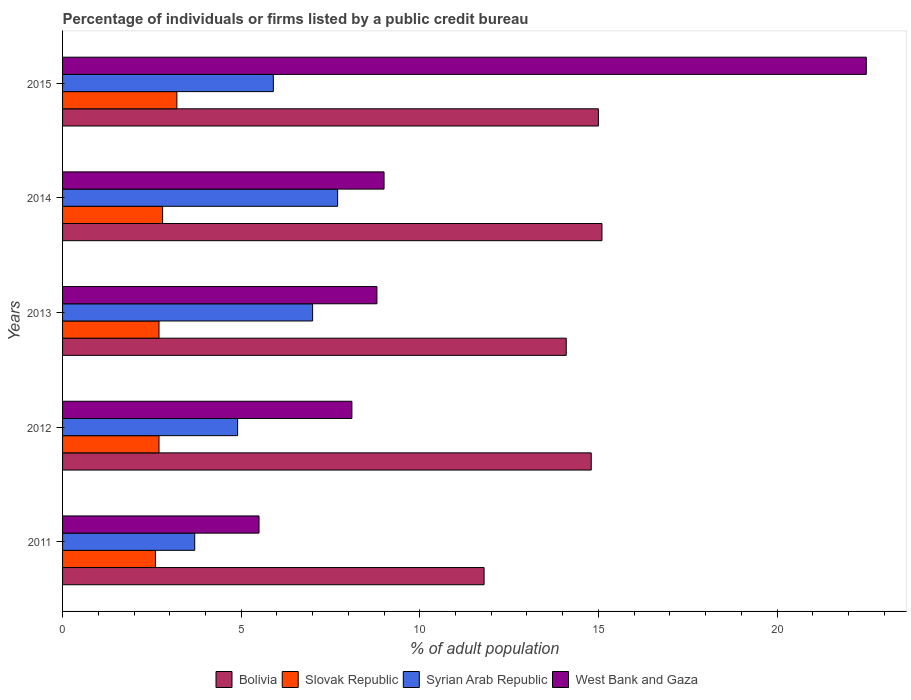How many different coloured bars are there?
Give a very brief answer. 4. How many groups of bars are there?
Provide a short and direct response. 5. Are the number of bars on each tick of the Y-axis equal?
Keep it short and to the point. Yes. How many bars are there on the 3rd tick from the top?
Your answer should be very brief. 4. How many bars are there on the 2nd tick from the bottom?
Your response must be concise. 4. In how many cases, is the number of bars for a given year not equal to the number of legend labels?
Offer a very short reply. 0. What is the percentage of population listed by a public credit bureau in Slovak Republic in 2013?
Offer a very short reply. 2.7. Across all years, what is the maximum percentage of population listed by a public credit bureau in Slovak Republic?
Give a very brief answer. 3.2. Across all years, what is the minimum percentage of population listed by a public credit bureau in Syrian Arab Republic?
Your answer should be compact. 3.7. In which year was the percentage of population listed by a public credit bureau in Slovak Republic maximum?
Keep it short and to the point. 2015. In which year was the percentage of population listed by a public credit bureau in Bolivia minimum?
Give a very brief answer. 2011. What is the difference between the percentage of population listed by a public credit bureau in Bolivia in 2011 and that in 2013?
Ensure brevity in your answer.  -2.3. What is the difference between the percentage of population listed by a public credit bureau in West Bank and Gaza in 2011 and the percentage of population listed by a public credit bureau in Syrian Arab Republic in 2015?
Keep it short and to the point. -0.4. What is the average percentage of population listed by a public credit bureau in West Bank and Gaza per year?
Provide a short and direct response. 10.78. In the year 2012, what is the difference between the percentage of population listed by a public credit bureau in Slovak Republic and percentage of population listed by a public credit bureau in West Bank and Gaza?
Make the answer very short. -5.4. In how many years, is the percentage of population listed by a public credit bureau in Bolivia greater than 8 %?
Your answer should be compact. 5. What is the ratio of the percentage of population listed by a public credit bureau in Bolivia in 2013 to that in 2014?
Offer a terse response. 0.93. Is the percentage of population listed by a public credit bureau in Bolivia in 2011 less than that in 2013?
Offer a very short reply. Yes. Is the difference between the percentage of population listed by a public credit bureau in Slovak Republic in 2014 and 2015 greater than the difference between the percentage of population listed by a public credit bureau in West Bank and Gaza in 2014 and 2015?
Offer a terse response. Yes. What is the difference between the highest and the lowest percentage of population listed by a public credit bureau in West Bank and Gaza?
Offer a terse response. 17. Is it the case that in every year, the sum of the percentage of population listed by a public credit bureau in Slovak Republic and percentage of population listed by a public credit bureau in Bolivia is greater than the sum of percentage of population listed by a public credit bureau in West Bank and Gaza and percentage of population listed by a public credit bureau in Syrian Arab Republic?
Keep it short and to the point. No. What does the 3rd bar from the top in 2012 represents?
Provide a short and direct response. Slovak Republic. What does the 2nd bar from the bottom in 2012 represents?
Offer a terse response. Slovak Republic. How many bars are there?
Ensure brevity in your answer.  20. Are all the bars in the graph horizontal?
Make the answer very short. Yes. How many years are there in the graph?
Offer a very short reply. 5. Where does the legend appear in the graph?
Provide a succinct answer. Bottom center. How many legend labels are there?
Keep it short and to the point. 4. What is the title of the graph?
Offer a very short reply. Percentage of individuals or firms listed by a public credit bureau. What is the label or title of the X-axis?
Provide a short and direct response. % of adult population. What is the % of adult population in Syrian Arab Republic in 2011?
Your response must be concise. 3.7. What is the % of adult population of West Bank and Gaza in 2011?
Ensure brevity in your answer.  5.5. What is the % of adult population in Bolivia in 2012?
Make the answer very short. 14.8. What is the % of adult population in Syrian Arab Republic in 2012?
Offer a terse response. 4.9. What is the % of adult population of West Bank and Gaza in 2012?
Make the answer very short. 8.1. What is the % of adult population of Syrian Arab Republic in 2013?
Your response must be concise. 7. What is the % of adult population in Syrian Arab Republic in 2014?
Your answer should be very brief. 7.7. What is the % of adult population in West Bank and Gaza in 2014?
Your response must be concise. 9. What is the % of adult population in Bolivia in 2015?
Offer a terse response. 15. What is the % of adult population of Slovak Republic in 2015?
Provide a succinct answer. 3.2. What is the % of adult population of Syrian Arab Republic in 2015?
Offer a very short reply. 5.9. Across all years, what is the minimum % of adult population in Bolivia?
Provide a succinct answer. 11.8. Across all years, what is the minimum % of adult population of Syrian Arab Republic?
Your answer should be very brief. 3.7. Across all years, what is the minimum % of adult population of West Bank and Gaza?
Provide a succinct answer. 5.5. What is the total % of adult population in Bolivia in the graph?
Your answer should be very brief. 70.8. What is the total % of adult population in Syrian Arab Republic in the graph?
Offer a very short reply. 29.2. What is the total % of adult population in West Bank and Gaza in the graph?
Your answer should be very brief. 53.9. What is the difference between the % of adult population of Bolivia in 2011 and that in 2012?
Offer a very short reply. -3. What is the difference between the % of adult population in Slovak Republic in 2011 and that in 2013?
Provide a succinct answer. -0.1. What is the difference between the % of adult population in Syrian Arab Republic in 2011 and that in 2013?
Make the answer very short. -3.3. What is the difference between the % of adult population in Bolivia in 2011 and that in 2014?
Provide a succinct answer. -3.3. What is the difference between the % of adult population of Bolivia in 2011 and that in 2015?
Provide a short and direct response. -3.2. What is the difference between the % of adult population of Slovak Republic in 2011 and that in 2015?
Your answer should be very brief. -0.6. What is the difference between the % of adult population in Syrian Arab Republic in 2011 and that in 2015?
Ensure brevity in your answer.  -2.2. What is the difference between the % of adult population in Syrian Arab Republic in 2012 and that in 2013?
Make the answer very short. -2.1. What is the difference between the % of adult population in West Bank and Gaza in 2012 and that in 2013?
Your response must be concise. -0.7. What is the difference between the % of adult population of Bolivia in 2012 and that in 2014?
Your response must be concise. -0.3. What is the difference between the % of adult population in Slovak Republic in 2012 and that in 2015?
Ensure brevity in your answer.  -0.5. What is the difference between the % of adult population in Syrian Arab Republic in 2012 and that in 2015?
Provide a succinct answer. -1. What is the difference between the % of adult population in West Bank and Gaza in 2012 and that in 2015?
Provide a short and direct response. -14.4. What is the difference between the % of adult population in Bolivia in 2013 and that in 2014?
Provide a succinct answer. -1. What is the difference between the % of adult population of Slovak Republic in 2013 and that in 2014?
Keep it short and to the point. -0.1. What is the difference between the % of adult population of Slovak Republic in 2013 and that in 2015?
Your answer should be very brief. -0.5. What is the difference between the % of adult population in Syrian Arab Republic in 2013 and that in 2015?
Your answer should be compact. 1.1. What is the difference between the % of adult population in West Bank and Gaza in 2013 and that in 2015?
Ensure brevity in your answer.  -13.7. What is the difference between the % of adult population in Syrian Arab Republic in 2014 and that in 2015?
Offer a very short reply. 1.8. What is the difference between the % of adult population in Bolivia in 2011 and the % of adult population in Syrian Arab Republic in 2012?
Provide a succinct answer. 6.9. What is the difference between the % of adult population in Slovak Republic in 2011 and the % of adult population in Syrian Arab Republic in 2012?
Offer a terse response. -2.3. What is the difference between the % of adult population of Slovak Republic in 2011 and the % of adult population of West Bank and Gaza in 2012?
Provide a short and direct response. -5.5. What is the difference between the % of adult population of Syrian Arab Republic in 2011 and the % of adult population of West Bank and Gaza in 2012?
Provide a succinct answer. -4.4. What is the difference between the % of adult population in Bolivia in 2011 and the % of adult population in Slovak Republic in 2013?
Provide a short and direct response. 9.1. What is the difference between the % of adult population in Bolivia in 2011 and the % of adult population in Syrian Arab Republic in 2013?
Offer a very short reply. 4.8. What is the difference between the % of adult population of Bolivia in 2011 and the % of adult population of West Bank and Gaza in 2013?
Provide a succinct answer. 3. What is the difference between the % of adult population of Slovak Republic in 2011 and the % of adult population of Syrian Arab Republic in 2013?
Your answer should be very brief. -4.4. What is the difference between the % of adult population of Bolivia in 2011 and the % of adult population of Syrian Arab Republic in 2014?
Give a very brief answer. 4.1. What is the difference between the % of adult population of Slovak Republic in 2011 and the % of adult population of West Bank and Gaza in 2014?
Your response must be concise. -6.4. What is the difference between the % of adult population of Bolivia in 2011 and the % of adult population of West Bank and Gaza in 2015?
Provide a succinct answer. -10.7. What is the difference between the % of adult population of Slovak Republic in 2011 and the % of adult population of West Bank and Gaza in 2015?
Make the answer very short. -19.9. What is the difference between the % of adult population in Syrian Arab Republic in 2011 and the % of adult population in West Bank and Gaza in 2015?
Offer a very short reply. -18.8. What is the difference between the % of adult population in Bolivia in 2012 and the % of adult population in Slovak Republic in 2013?
Offer a terse response. 12.1. What is the difference between the % of adult population of Syrian Arab Republic in 2012 and the % of adult population of West Bank and Gaza in 2013?
Your answer should be compact. -3.9. What is the difference between the % of adult population in Bolivia in 2012 and the % of adult population in West Bank and Gaza in 2014?
Provide a succinct answer. 5.8. What is the difference between the % of adult population of Bolivia in 2012 and the % of adult population of Slovak Republic in 2015?
Keep it short and to the point. 11.6. What is the difference between the % of adult population of Bolivia in 2012 and the % of adult population of West Bank and Gaza in 2015?
Provide a succinct answer. -7.7. What is the difference between the % of adult population in Slovak Republic in 2012 and the % of adult population in West Bank and Gaza in 2015?
Your answer should be very brief. -19.8. What is the difference between the % of adult population of Syrian Arab Republic in 2012 and the % of adult population of West Bank and Gaza in 2015?
Your answer should be very brief. -17.6. What is the difference between the % of adult population in Bolivia in 2013 and the % of adult population in Slovak Republic in 2014?
Make the answer very short. 11.3. What is the difference between the % of adult population in Bolivia in 2013 and the % of adult population in West Bank and Gaza in 2014?
Offer a very short reply. 5.1. What is the difference between the % of adult population of Slovak Republic in 2013 and the % of adult population of West Bank and Gaza in 2014?
Offer a terse response. -6.3. What is the difference between the % of adult population of Syrian Arab Republic in 2013 and the % of adult population of West Bank and Gaza in 2014?
Your response must be concise. -2. What is the difference between the % of adult population of Bolivia in 2013 and the % of adult population of Syrian Arab Republic in 2015?
Make the answer very short. 8.2. What is the difference between the % of adult population of Slovak Republic in 2013 and the % of adult population of West Bank and Gaza in 2015?
Keep it short and to the point. -19.8. What is the difference between the % of adult population of Syrian Arab Republic in 2013 and the % of adult population of West Bank and Gaza in 2015?
Your answer should be very brief. -15.5. What is the difference between the % of adult population of Bolivia in 2014 and the % of adult population of Syrian Arab Republic in 2015?
Provide a succinct answer. 9.2. What is the difference between the % of adult population in Bolivia in 2014 and the % of adult population in West Bank and Gaza in 2015?
Your response must be concise. -7.4. What is the difference between the % of adult population of Slovak Republic in 2014 and the % of adult population of West Bank and Gaza in 2015?
Make the answer very short. -19.7. What is the difference between the % of adult population of Syrian Arab Republic in 2014 and the % of adult population of West Bank and Gaza in 2015?
Provide a short and direct response. -14.8. What is the average % of adult population in Bolivia per year?
Make the answer very short. 14.16. What is the average % of adult population in Slovak Republic per year?
Offer a very short reply. 2.8. What is the average % of adult population of Syrian Arab Republic per year?
Offer a very short reply. 5.84. What is the average % of adult population in West Bank and Gaza per year?
Provide a short and direct response. 10.78. In the year 2011, what is the difference between the % of adult population of Bolivia and % of adult population of Syrian Arab Republic?
Provide a succinct answer. 8.1. In the year 2011, what is the difference between the % of adult population of Bolivia and % of adult population of West Bank and Gaza?
Offer a very short reply. 6.3. In the year 2012, what is the difference between the % of adult population of Bolivia and % of adult population of Slovak Republic?
Give a very brief answer. 12.1. In the year 2012, what is the difference between the % of adult population of Slovak Republic and % of adult population of Syrian Arab Republic?
Your answer should be very brief. -2.2. In the year 2012, what is the difference between the % of adult population of Syrian Arab Republic and % of adult population of West Bank and Gaza?
Your response must be concise. -3.2. In the year 2013, what is the difference between the % of adult population of Bolivia and % of adult population of Slovak Republic?
Give a very brief answer. 11.4. In the year 2013, what is the difference between the % of adult population in Bolivia and % of adult population in Syrian Arab Republic?
Make the answer very short. 7.1. In the year 2013, what is the difference between the % of adult population of Bolivia and % of adult population of West Bank and Gaza?
Provide a succinct answer. 5.3. In the year 2013, what is the difference between the % of adult population of Syrian Arab Republic and % of adult population of West Bank and Gaza?
Provide a short and direct response. -1.8. In the year 2014, what is the difference between the % of adult population of Bolivia and % of adult population of West Bank and Gaza?
Your answer should be compact. 6.1. In the year 2014, what is the difference between the % of adult population of Syrian Arab Republic and % of adult population of West Bank and Gaza?
Keep it short and to the point. -1.3. In the year 2015, what is the difference between the % of adult population of Bolivia and % of adult population of Slovak Republic?
Give a very brief answer. 11.8. In the year 2015, what is the difference between the % of adult population of Bolivia and % of adult population of Syrian Arab Republic?
Your response must be concise. 9.1. In the year 2015, what is the difference between the % of adult population in Bolivia and % of adult population in West Bank and Gaza?
Offer a terse response. -7.5. In the year 2015, what is the difference between the % of adult population in Slovak Republic and % of adult population in Syrian Arab Republic?
Offer a very short reply. -2.7. In the year 2015, what is the difference between the % of adult population in Slovak Republic and % of adult population in West Bank and Gaza?
Your answer should be compact. -19.3. In the year 2015, what is the difference between the % of adult population of Syrian Arab Republic and % of adult population of West Bank and Gaza?
Your answer should be compact. -16.6. What is the ratio of the % of adult population of Bolivia in 2011 to that in 2012?
Provide a short and direct response. 0.8. What is the ratio of the % of adult population in Slovak Republic in 2011 to that in 2012?
Your answer should be very brief. 0.96. What is the ratio of the % of adult population in Syrian Arab Republic in 2011 to that in 2012?
Your response must be concise. 0.76. What is the ratio of the % of adult population in West Bank and Gaza in 2011 to that in 2012?
Keep it short and to the point. 0.68. What is the ratio of the % of adult population in Bolivia in 2011 to that in 2013?
Your response must be concise. 0.84. What is the ratio of the % of adult population in Syrian Arab Republic in 2011 to that in 2013?
Ensure brevity in your answer.  0.53. What is the ratio of the % of adult population of West Bank and Gaza in 2011 to that in 2013?
Provide a short and direct response. 0.62. What is the ratio of the % of adult population in Bolivia in 2011 to that in 2014?
Offer a terse response. 0.78. What is the ratio of the % of adult population in Syrian Arab Republic in 2011 to that in 2014?
Offer a very short reply. 0.48. What is the ratio of the % of adult population of West Bank and Gaza in 2011 to that in 2014?
Keep it short and to the point. 0.61. What is the ratio of the % of adult population of Bolivia in 2011 to that in 2015?
Make the answer very short. 0.79. What is the ratio of the % of adult population in Slovak Republic in 2011 to that in 2015?
Provide a succinct answer. 0.81. What is the ratio of the % of adult population of Syrian Arab Republic in 2011 to that in 2015?
Offer a very short reply. 0.63. What is the ratio of the % of adult population in West Bank and Gaza in 2011 to that in 2015?
Your answer should be compact. 0.24. What is the ratio of the % of adult population of Bolivia in 2012 to that in 2013?
Make the answer very short. 1.05. What is the ratio of the % of adult population in Slovak Republic in 2012 to that in 2013?
Provide a short and direct response. 1. What is the ratio of the % of adult population in Syrian Arab Republic in 2012 to that in 2013?
Keep it short and to the point. 0.7. What is the ratio of the % of adult population of West Bank and Gaza in 2012 to that in 2013?
Offer a terse response. 0.92. What is the ratio of the % of adult population in Bolivia in 2012 to that in 2014?
Offer a very short reply. 0.98. What is the ratio of the % of adult population of Slovak Republic in 2012 to that in 2014?
Your response must be concise. 0.96. What is the ratio of the % of adult population of Syrian Arab Republic in 2012 to that in 2014?
Your response must be concise. 0.64. What is the ratio of the % of adult population in Bolivia in 2012 to that in 2015?
Your answer should be compact. 0.99. What is the ratio of the % of adult population of Slovak Republic in 2012 to that in 2015?
Ensure brevity in your answer.  0.84. What is the ratio of the % of adult population in Syrian Arab Republic in 2012 to that in 2015?
Keep it short and to the point. 0.83. What is the ratio of the % of adult population of West Bank and Gaza in 2012 to that in 2015?
Your response must be concise. 0.36. What is the ratio of the % of adult population in Bolivia in 2013 to that in 2014?
Provide a short and direct response. 0.93. What is the ratio of the % of adult population in Slovak Republic in 2013 to that in 2014?
Ensure brevity in your answer.  0.96. What is the ratio of the % of adult population of Syrian Arab Republic in 2013 to that in 2014?
Offer a very short reply. 0.91. What is the ratio of the % of adult population in West Bank and Gaza in 2013 to that in 2014?
Offer a very short reply. 0.98. What is the ratio of the % of adult population of Bolivia in 2013 to that in 2015?
Your response must be concise. 0.94. What is the ratio of the % of adult population of Slovak Republic in 2013 to that in 2015?
Provide a short and direct response. 0.84. What is the ratio of the % of adult population in Syrian Arab Republic in 2013 to that in 2015?
Provide a short and direct response. 1.19. What is the ratio of the % of adult population in West Bank and Gaza in 2013 to that in 2015?
Ensure brevity in your answer.  0.39. What is the ratio of the % of adult population in Bolivia in 2014 to that in 2015?
Make the answer very short. 1.01. What is the ratio of the % of adult population in Syrian Arab Republic in 2014 to that in 2015?
Your answer should be compact. 1.31. What is the difference between the highest and the second highest % of adult population of Bolivia?
Offer a very short reply. 0.1. What is the difference between the highest and the second highest % of adult population in West Bank and Gaza?
Provide a short and direct response. 13.5. What is the difference between the highest and the lowest % of adult population in Bolivia?
Offer a very short reply. 3.3. What is the difference between the highest and the lowest % of adult population of Slovak Republic?
Offer a very short reply. 0.6. 